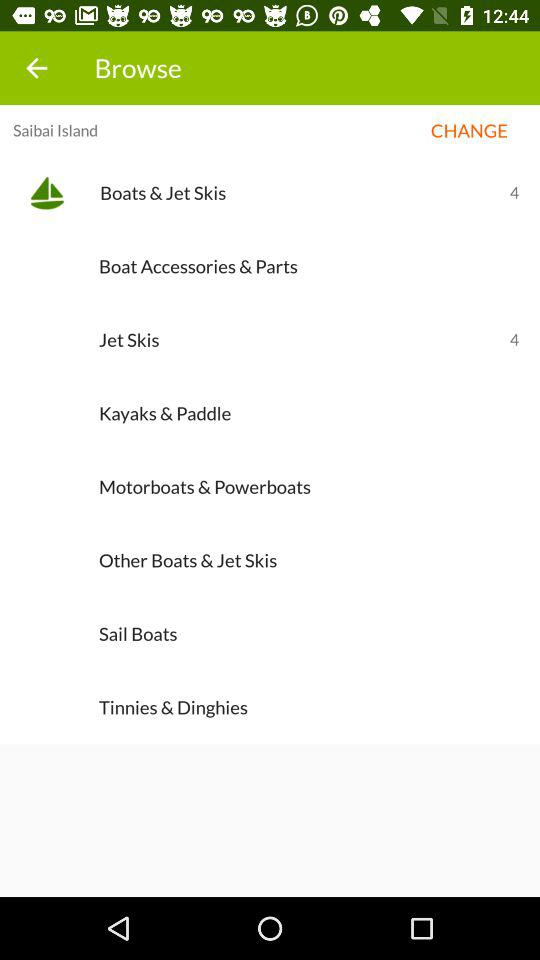What is the current location? The current location is Saibai Island. 